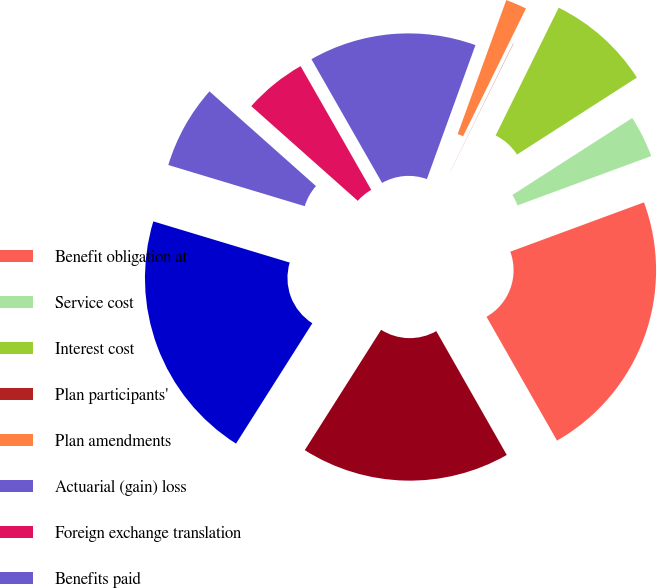Convert chart to OTSL. <chart><loc_0><loc_0><loc_500><loc_500><pie_chart><fcel>Benefit obligation at<fcel>Service cost<fcel>Interest cost<fcel>Plan participants'<fcel>Plan amendments<fcel>Actuarial (gain) loss<fcel>Foreign exchange translation<fcel>Benefits paid<fcel>Benefit obligation at end of<fcel>Fair value of plan assets at<nl><fcel>22.39%<fcel>3.46%<fcel>8.62%<fcel>0.02%<fcel>1.74%<fcel>13.79%<fcel>5.18%<fcel>6.9%<fcel>20.67%<fcel>17.23%<nl></chart> 